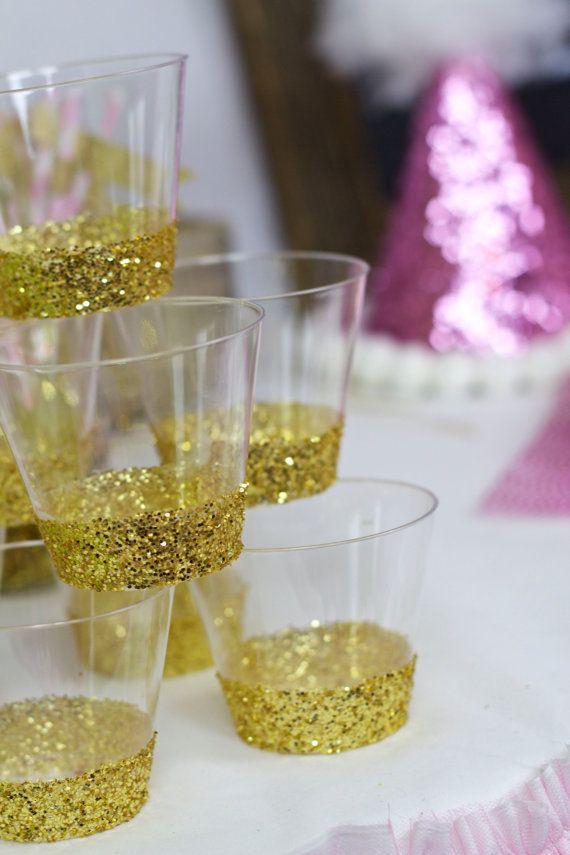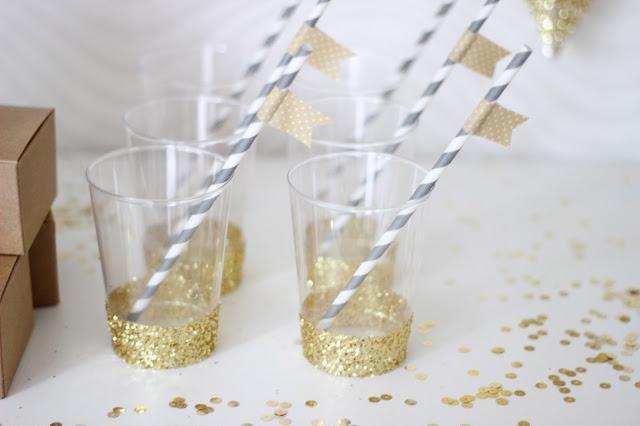The first image is the image on the left, the second image is the image on the right. Evaluate the accuracy of this statement regarding the images: "Both images have pink lemonade in glass dishes.". Is it true? Answer yes or no. No. The first image is the image on the left, the second image is the image on the right. Considering the images on both sides, is "There are straws in the right image." valid? Answer yes or no. Yes. 